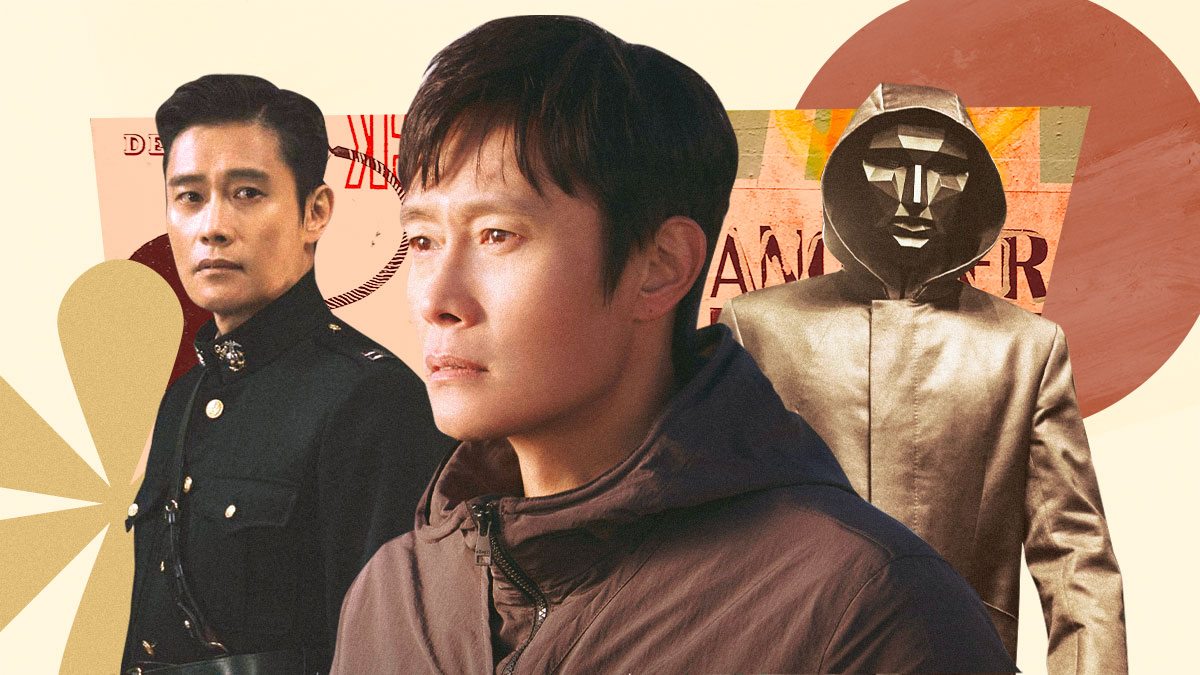What do you see happening in this image? The image showcases the versatile nature of an actor, depicting him in three distinct roles. To the left, he appears in a formal military uniform, complete with gold epaulettes and a red collar, indicating a role of authority or leadership. In the center, he takes on a more casual and introspective demeanor, dressed in a brown jacket with a serious expression, suggesting contemplation or a more personal story. On the right, the actor transforms into a mysterious figure, his face concealed by a mask and his outfit consisting of a gold hooded jacket, evoking a sense of enigma and intrigue. The background, an abstract canvas of warm colors such as orange, yellow, and red, further accentuates the diversity in his roles and the emotions conveyed. 